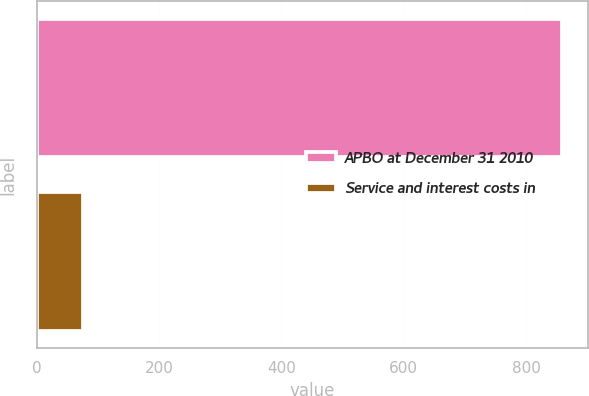<chart> <loc_0><loc_0><loc_500><loc_500><bar_chart><fcel>APBO at December 31 2010<fcel>Service and interest costs in<nl><fcel>858<fcel>76<nl></chart> 